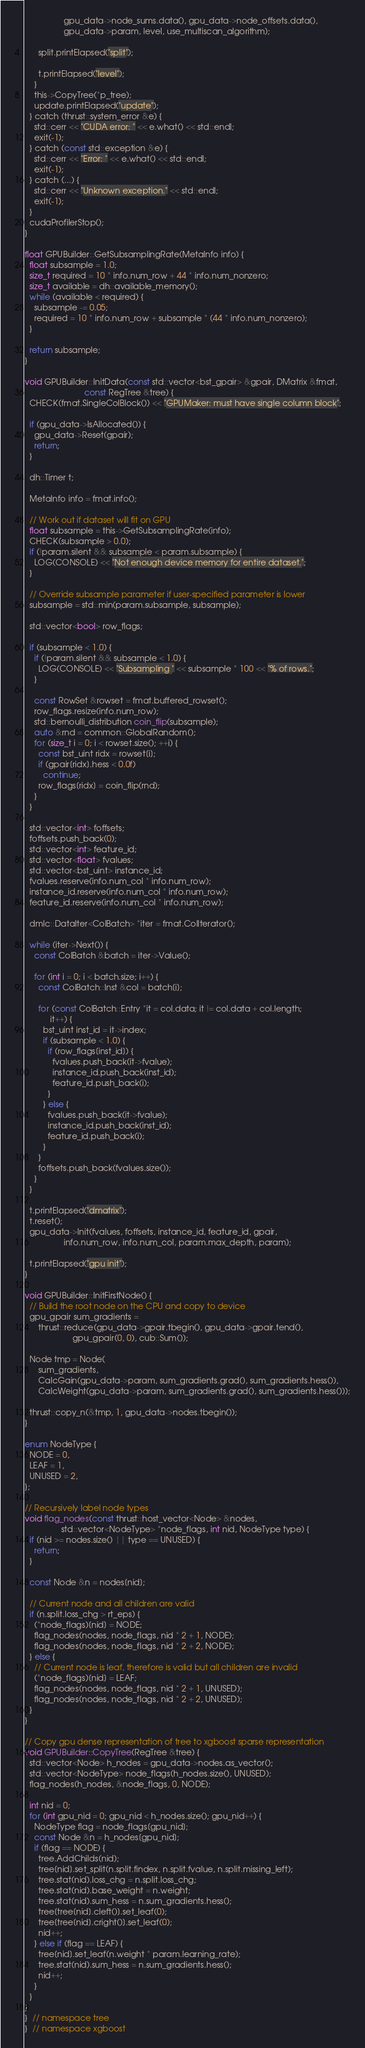Convert code to text. <code><loc_0><loc_0><loc_500><loc_500><_Cuda_>                 gpu_data->node_sums.data(), gpu_data->node_offsets.data(),
                 gpu_data->param, level, use_multiscan_algorithm);

      split.printElapsed("split");

      t.printElapsed("level");
    }
    this->CopyTree(*p_tree);
    update.printElapsed("update");
  } catch (thrust::system_error &e) {
    std::cerr << "CUDA error: " << e.what() << std::endl;
    exit(-1);
  } catch (const std::exception &e) {
    std::cerr << "Error: " << e.what() << std::endl;
    exit(-1);
  } catch (...) {
    std::cerr << "Unknown exception." << std::endl;
    exit(-1);
  }
  cudaProfilerStop();
}

float GPUBuilder::GetSubsamplingRate(MetaInfo info) {
  float subsample = 1.0;
  size_t required = 10 * info.num_row + 44 * info.num_nonzero;
  size_t available = dh::available_memory();
  while (available < required) {
    subsample -= 0.05;
    required = 10 * info.num_row + subsample * (44 * info.num_nonzero);
  }

  return subsample;
}

void GPUBuilder::InitData(const std::vector<bst_gpair> &gpair, DMatrix &fmat,
                          const RegTree &tree) {
  CHECK(fmat.SingleColBlock()) << "GPUMaker: must have single column block";

  if (gpu_data->IsAllocated()) {
    gpu_data->Reset(gpair);
    return;
  }

  dh::Timer t;

  MetaInfo info = fmat.info();

  // Work out if dataset will fit on GPU
  float subsample = this->GetSubsamplingRate(info);
  CHECK(subsample > 0.0);
  if (!param.silent && subsample < param.subsample) {
    LOG(CONSOLE) << "Not enough device memory for entire dataset.";
  }

  // Override subsample parameter if user-specified parameter is lower
  subsample = std::min(param.subsample, subsample);

  std::vector<bool> row_flags;

  if (subsample < 1.0) {
    if (!param.silent && subsample < 1.0) {
      LOG(CONSOLE) << "Subsampling " << subsample * 100 << "% of rows.";
    }

    const RowSet &rowset = fmat.buffered_rowset();
    row_flags.resize(info.num_row);
    std::bernoulli_distribution coin_flip(subsample);
    auto &rnd = common::GlobalRandom();
    for (size_t i = 0; i < rowset.size(); ++i) {
      const bst_uint ridx = rowset[i];
      if (gpair[ridx].hess < 0.0f)
        continue;
      row_flags[ridx] = coin_flip(rnd);
    }
  }

  std::vector<int> foffsets;
  foffsets.push_back(0);
  std::vector<int> feature_id;
  std::vector<float> fvalues;
  std::vector<bst_uint> instance_id;
  fvalues.reserve(info.num_col * info.num_row);
  instance_id.reserve(info.num_col * info.num_row);
  feature_id.reserve(info.num_col * info.num_row);

  dmlc::DataIter<ColBatch> *iter = fmat.ColIterator();

  while (iter->Next()) {
    const ColBatch &batch = iter->Value();

    for (int i = 0; i < batch.size; i++) {
      const ColBatch::Inst &col = batch[i];

      for (const ColBatch::Entry *it = col.data; it != col.data + col.length;
           it++) {
        bst_uint inst_id = it->index;
        if (subsample < 1.0) {
          if (row_flags[inst_id]) {
            fvalues.push_back(it->fvalue);
            instance_id.push_back(inst_id);
            feature_id.push_back(i);
          }
        } else {
          fvalues.push_back(it->fvalue);
          instance_id.push_back(inst_id);
          feature_id.push_back(i);
        }
      }
      foffsets.push_back(fvalues.size());
    }
  }

  t.printElapsed("dmatrix");
  t.reset();
  gpu_data->Init(fvalues, foffsets, instance_id, feature_id, gpair,
                 info.num_row, info.num_col, param.max_depth, param);

  t.printElapsed("gpu init");
}

void GPUBuilder::InitFirstNode() {
  // Build the root node on the CPU and copy to device
  gpu_gpair sum_gradients =
      thrust::reduce(gpu_data->gpair.tbegin(), gpu_data->gpair.tend(),
                     gpu_gpair(0, 0), cub::Sum());

  Node tmp = Node(
      sum_gradients,
      CalcGain(gpu_data->param, sum_gradients.grad(), sum_gradients.hess()),
      CalcWeight(gpu_data->param, sum_gradients.grad(), sum_gradients.hess()));

  thrust::copy_n(&tmp, 1, gpu_data->nodes.tbegin());
}

enum NodeType {
  NODE = 0,
  LEAF = 1,
  UNUSED = 2,
};

// Recursively label node types
void flag_nodes(const thrust::host_vector<Node> &nodes,
                std::vector<NodeType> *node_flags, int nid, NodeType type) {
  if (nid >= nodes.size() || type == UNUSED) {
    return;
  }

  const Node &n = nodes[nid];

  // Current node and all children are valid
  if (n.split.loss_chg > rt_eps) {
    (*node_flags)[nid] = NODE;
    flag_nodes(nodes, node_flags, nid * 2 + 1, NODE);
    flag_nodes(nodes, node_flags, nid * 2 + 2, NODE);
  } else {
    // Current node is leaf, therefore is valid but all children are invalid
    (*node_flags)[nid] = LEAF;
    flag_nodes(nodes, node_flags, nid * 2 + 1, UNUSED);
    flag_nodes(nodes, node_flags, nid * 2 + 2, UNUSED);
  }
}

// Copy gpu dense representation of tree to xgboost sparse representation
void GPUBuilder::CopyTree(RegTree &tree) {
  std::vector<Node> h_nodes = gpu_data->nodes.as_vector();
  std::vector<NodeType> node_flags(h_nodes.size(), UNUSED);
  flag_nodes(h_nodes, &node_flags, 0, NODE);

  int nid = 0;
  for (int gpu_nid = 0; gpu_nid < h_nodes.size(); gpu_nid++) {
    NodeType flag = node_flags[gpu_nid];
    const Node &n = h_nodes[gpu_nid];
    if (flag == NODE) {
      tree.AddChilds(nid);
      tree[nid].set_split(n.split.findex, n.split.fvalue, n.split.missing_left);
      tree.stat(nid).loss_chg = n.split.loss_chg;
      tree.stat(nid).base_weight = n.weight;
      tree.stat(nid).sum_hess = n.sum_gradients.hess();
      tree[tree[nid].cleft()].set_leaf(0);
      tree[tree[nid].cright()].set_leaf(0);
      nid++;
    } else if (flag == LEAF) {
      tree[nid].set_leaf(n.weight * param.learning_rate);
      tree.stat(nid).sum_hess = n.sum_gradients.hess();
      nid++;
    }
  }
}
}  // namespace tree
}  // namespace xgboost
</code> 